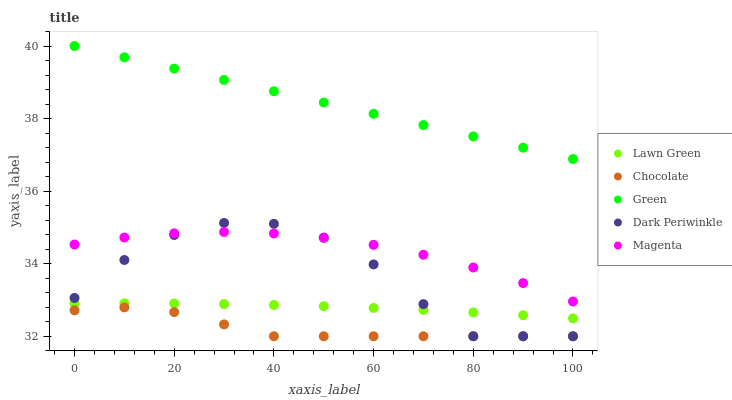Does Chocolate have the minimum area under the curve?
Answer yes or no. Yes. Does Green have the maximum area under the curve?
Answer yes or no. Yes. Does Magenta have the minimum area under the curve?
Answer yes or no. No. Does Magenta have the maximum area under the curve?
Answer yes or no. No. Is Green the smoothest?
Answer yes or no. Yes. Is Dark Periwinkle the roughest?
Answer yes or no. Yes. Is Magenta the smoothest?
Answer yes or no. No. Is Magenta the roughest?
Answer yes or no. No. Does Dark Periwinkle have the lowest value?
Answer yes or no. Yes. Does Magenta have the lowest value?
Answer yes or no. No. Does Green have the highest value?
Answer yes or no. Yes. Does Magenta have the highest value?
Answer yes or no. No. Is Lawn Green less than Magenta?
Answer yes or no. Yes. Is Green greater than Dark Periwinkle?
Answer yes or no. Yes. Does Dark Periwinkle intersect Lawn Green?
Answer yes or no. Yes. Is Dark Periwinkle less than Lawn Green?
Answer yes or no. No. Is Dark Periwinkle greater than Lawn Green?
Answer yes or no. No. Does Lawn Green intersect Magenta?
Answer yes or no. No. 